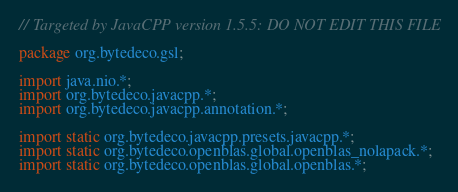<code> <loc_0><loc_0><loc_500><loc_500><_Java_>// Targeted by JavaCPP version 1.5.5: DO NOT EDIT THIS FILE

package org.bytedeco.gsl;

import java.nio.*;
import org.bytedeco.javacpp.*;
import org.bytedeco.javacpp.annotation.*;

import static org.bytedeco.javacpp.presets.javacpp.*;
import static org.bytedeco.openblas.global.openblas_nolapack.*;
import static org.bytedeco.openblas.global.openblas.*;
</code> 